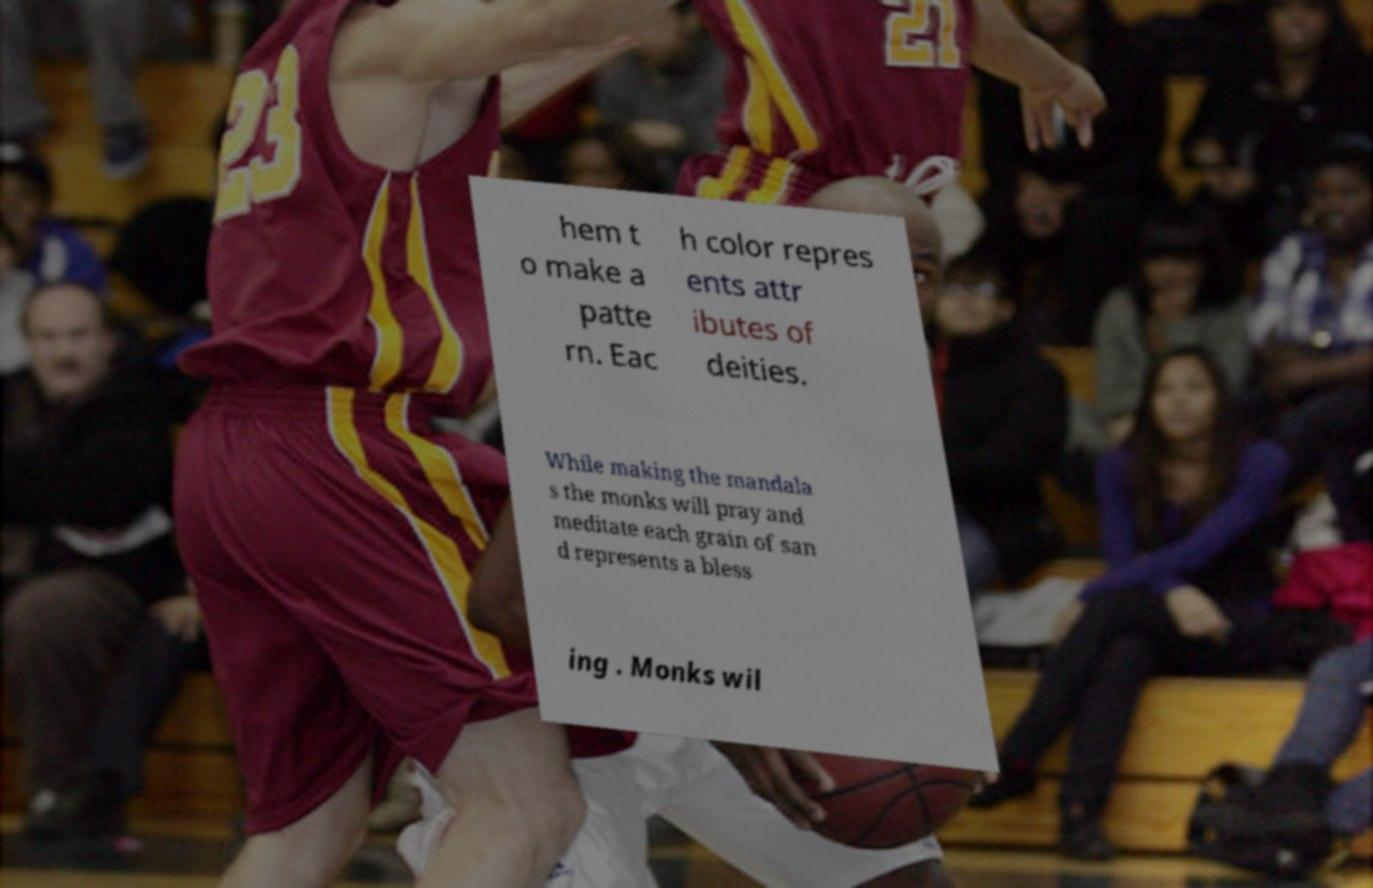Could you extract and type out the text from this image? hem t o make a patte rn. Eac h color repres ents attr ibutes of deities. While making the mandala s the monks will pray and meditate each grain of san d represents a bless ing . Monks wil 